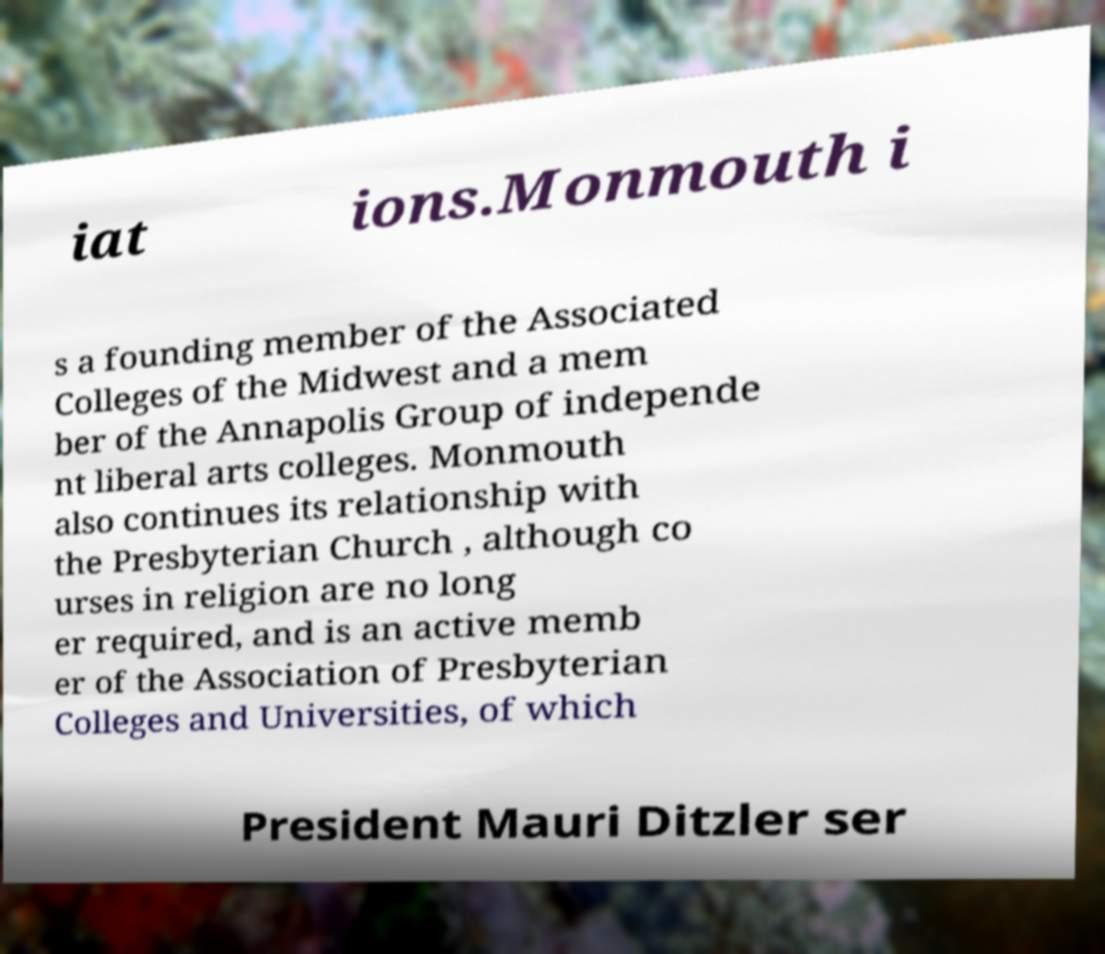Can you accurately transcribe the text from the provided image for me? iat ions.Monmouth i s a founding member of the Associated Colleges of the Midwest and a mem ber of the Annapolis Group of independe nt liberal arts colleges. Monmouth also continues its relationship with the Presbyterian Church , although co urses in religion are no long er required, and is an active memb er of the Association of Presbyterian Colleges and Universities, of which President Mauri Ditzler ser 